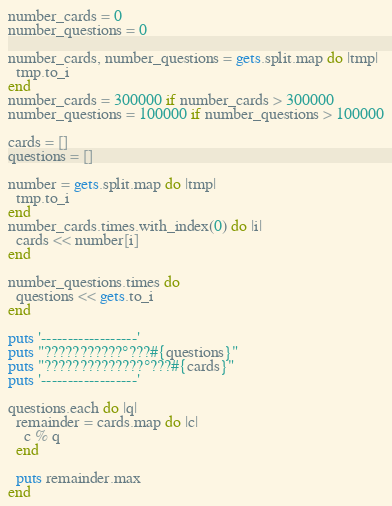<code> <loc_0><loc_0><loc_500><loc_500><_Ruby_>number_cards = 0
number_questions = 0

number_cards, number_questions = gets.split.map do |tmp|
  tmp.to_i
end
number_cards = 300000 if number_cards > 300000
number_questions = 100000 if number_questions > 100000

cards = []
questions = []

number = gets.split.map do |tmp|
  tmp.to_i
end
number_cards.times.with_index(0) do |i|
  cards << number[i]
end

number_questions.times do
  questions << gets.to_i
end

puts '------------------'
puts "???????????°???#{questions}"
puts "??????????????°???#{cards}"
puts '------------------'

questions.each do |q|
  remainder = cards.map do |c|
    c % q
  end

  puts remainder.max
end</code> 